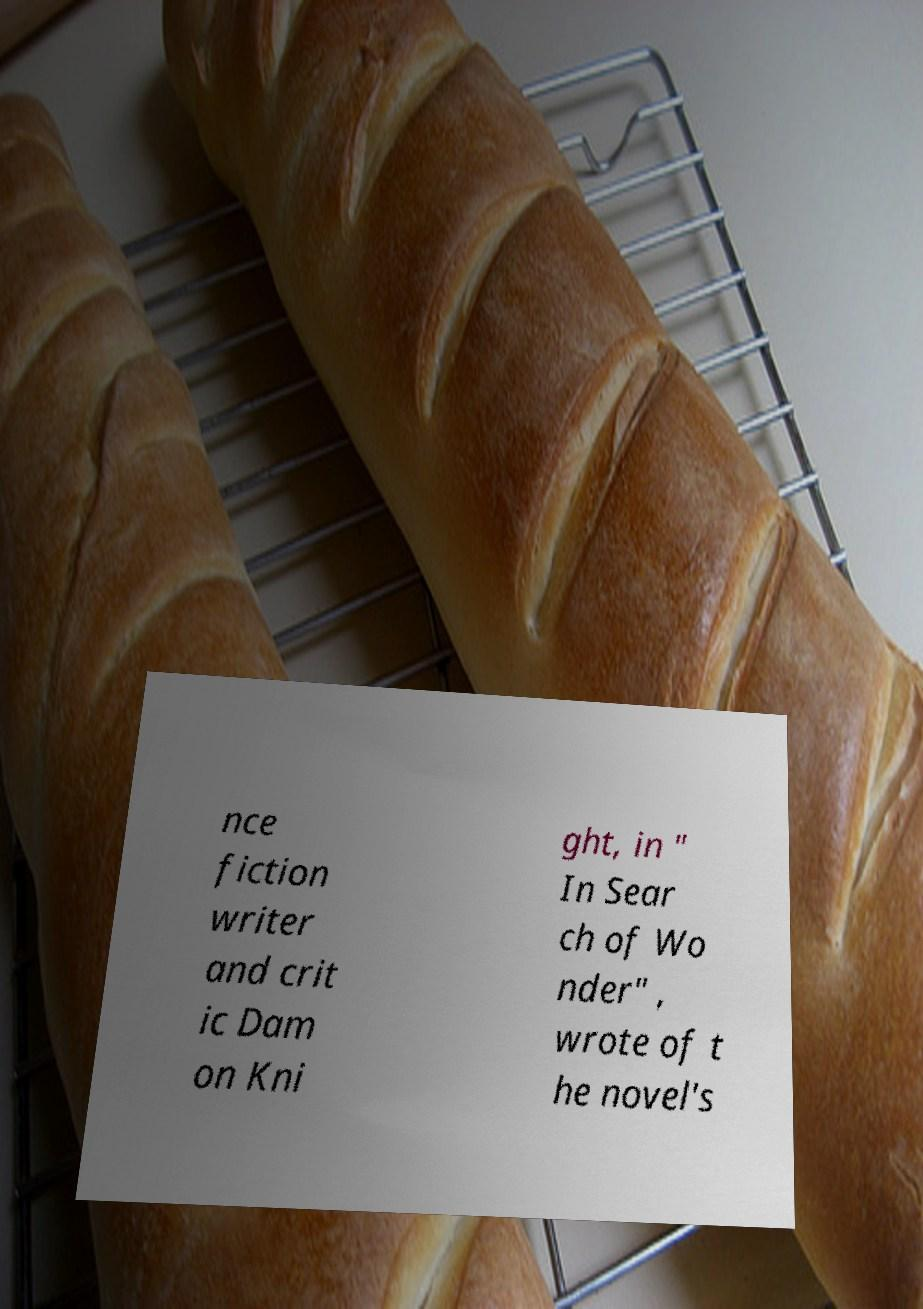Can you read and provide the text displayed in the image?This photo seems to have some interesting text. Can you extract and type it out for me? nce fiction writer and crit ic Dam on Kni ght, in " In Sear ch of Wo nder" , wrote of t he novel's 